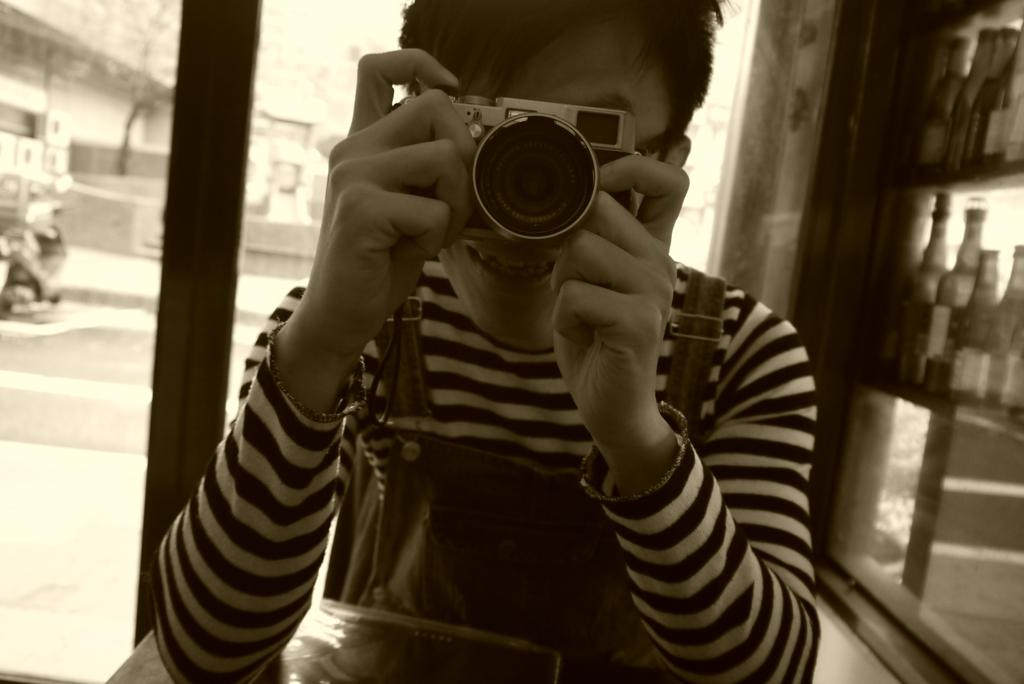What is the color scheme of the image? The image is black and white. Who or what is present in the image? There is a man in the image. What is the man holding in his hands? The man is holding a camera in his hands. What other objects can be seen in the image? There is a pole and bottles in the image. Can you see the queen walking on the grass in the image? There is no queen or grass present in the image. 